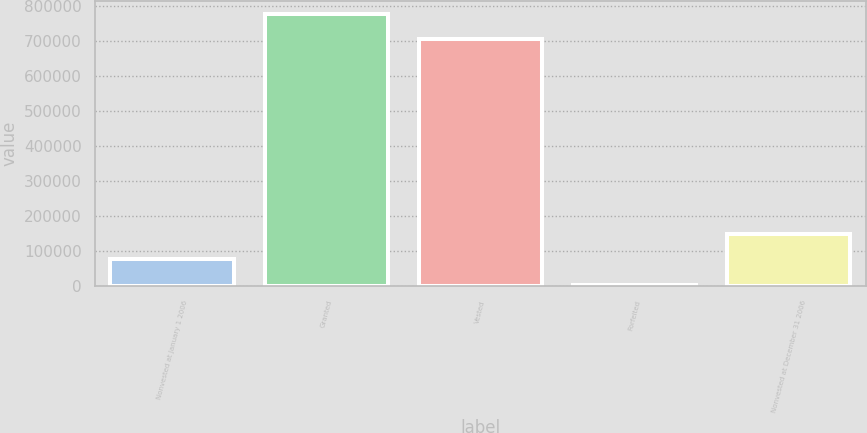Convert chart to OTSL. <chart><loc_0><loc_0><loc_500><loc_500><bar_chart><fcel>Nonvested at January 1 2006<fcel>Granted<fcel>Vested<fcel>Forfeited<fcel>Nonvested at December 31 2006<nl><fcel>77038.2<fcel>776331<fcel>704385<fcel>5092<fcel>148984<nl></chart> 